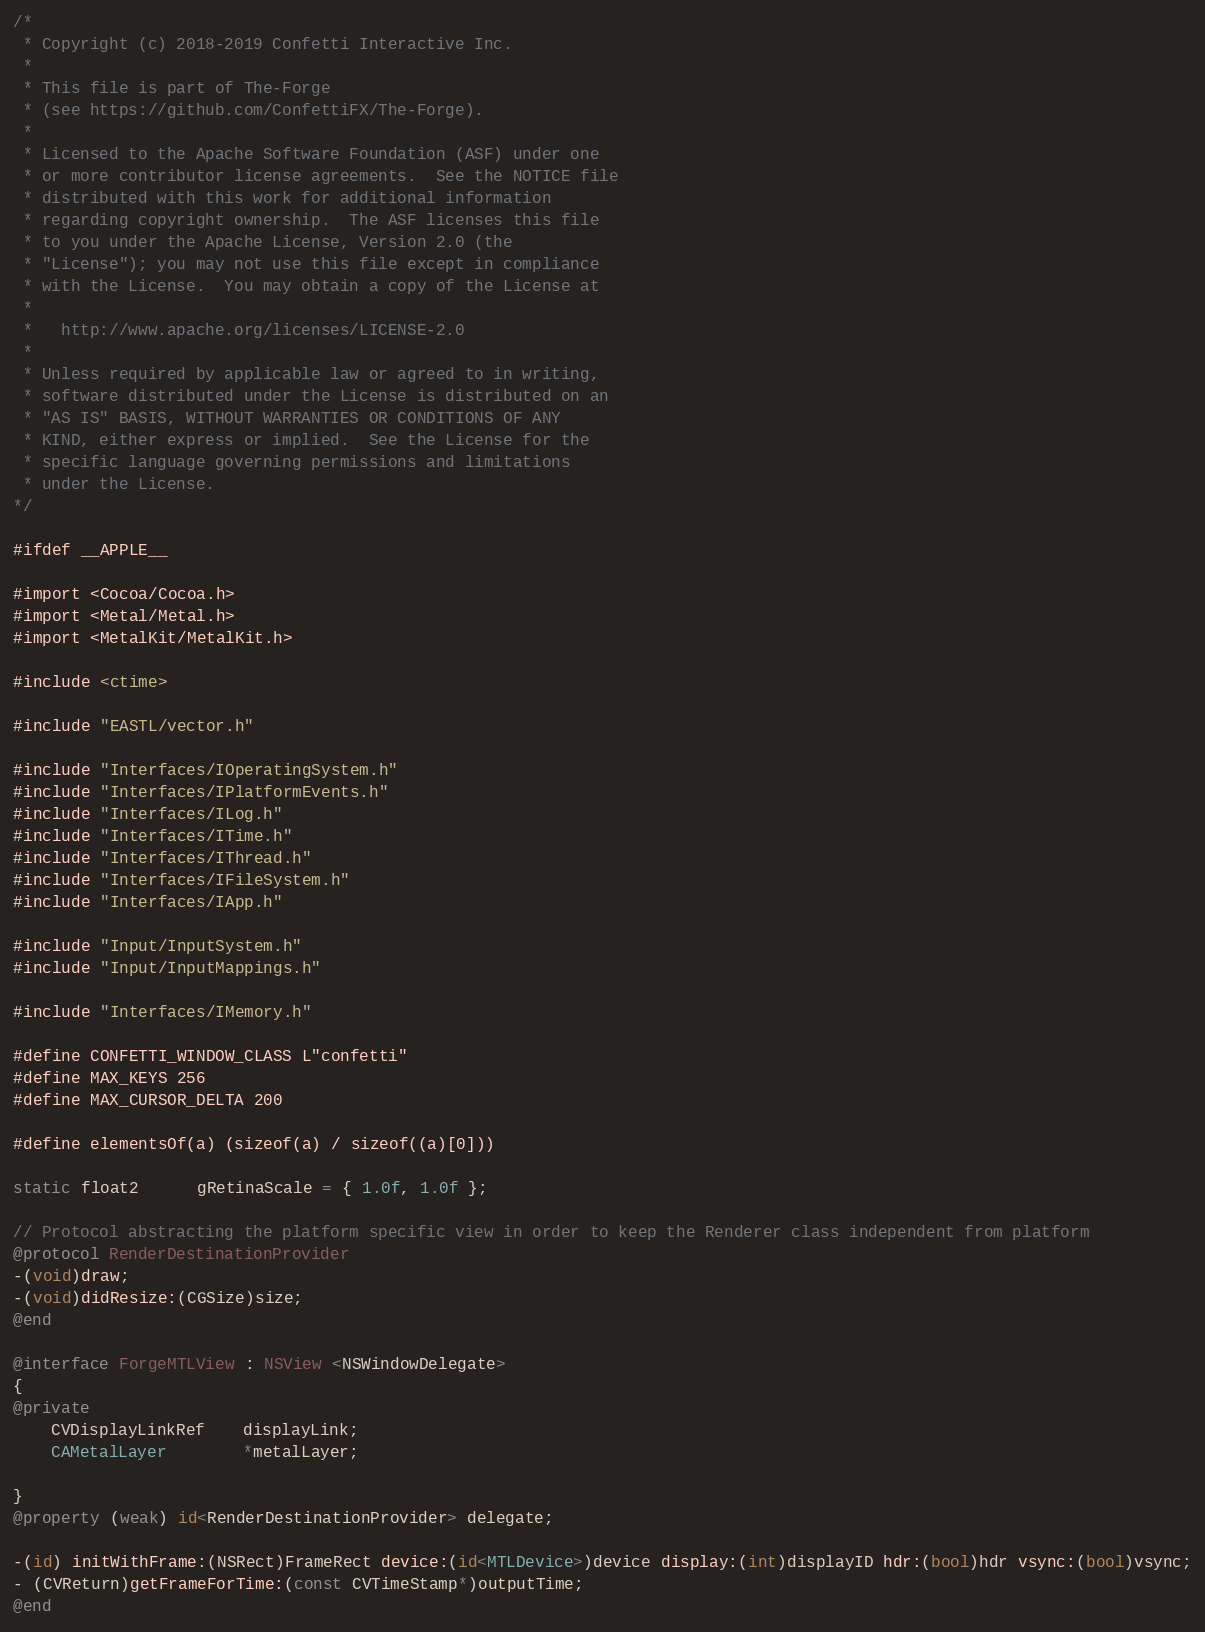Convert code to text. <code><loc_0><loc_0><loc_500><loc_500><_ObjectiveC_>/*
 * Copyright (c) 2018-2019 Confetti Interactive Inc.
 *
 * This file is part of The-Forge
 * (see https://github.com/ConfettiFX/The-Forge).
 *
 * Licensed to the Apache Software Foundation (ASF) under one
 * or more contributor license agreements.  See the NOTICE file
 * distributed with this work for additional information
 * regarding copyright ownership.  The ASF licenses this file
 * to you under the Apache License, Version 2.0 (the
 * "License"); you may not use this file except in compliance
 * with the License.  You may obtain a copy of the License at
 *
 *   http://www.apache.org/licenses/LICENSE-2.0
 *
 * Unless required by applicable law or agreed to in writing,
 * software distributed under the License is distributed on an
 * "AS IS" BASIS, WITHOUT WARRANTIES OR CONDITIONS OF ANY
 * KIND, either express or implied.  See the License for the
 * specific language governing permissions and limitations
 * under the License.
*/

#ifdef __APPLE__

#import <Cocoa/Cocoa.h>
#import <Metal/Metal.h>
#import <MetalKit/MetalKit.h>

#include <ctime>

#include "EASTL/vector.h"

#include "Interfaces/IOperatingSystem.h"
#include "Interfaces/IPlatformEvents.h"
#include "Interfaces/ILog.h"
#include "Interfaces/ITime.h"
#include "Interfaces/IThread.h"
#include "Interfaces/IFileSystem.h"
#include "Interfaces/IApp.h"

#include "Input/InputSystem.h"
#include "Input/InputMappings.h"

#include "Interfaces/IMemory.h"

#define CONFETTI_WINDOW_CLASS L"confetti"
#define MAX_KEYS 256
#define MAX_CURSOR_DELTA 200

#define elementsOf(a) (sizeof(a) / sizeof((a)[0]))

static float2      gRetinaScale = { 1.0f, 1.0f };

// Protocol abstracting the platform specific view in order to keep the Renderer class independent from platform
@protocol RenderDestinationProvider
-(void)draw;
-(void)didResize:(CGSize)size;
@end

@interface ForgeMTLView : NSView <NSWindowDelegate>
{
@private
    CVDisplayLinkRef    displayLink;
    CAMetalLayer        *metalLayer;
    
}
@property (weak) id<RenderDestinationProvider> delegate;

-(id) initWithFrame:(NSRect)FrameRect device:(id<MTLDevice>)device display:(int)displayID hdr:(bool)hdr vsync:(bool)vsync;
- (CVReturn)getFrameForTime:(const CVTimeStamp*)outputTime;
@end
</code> 